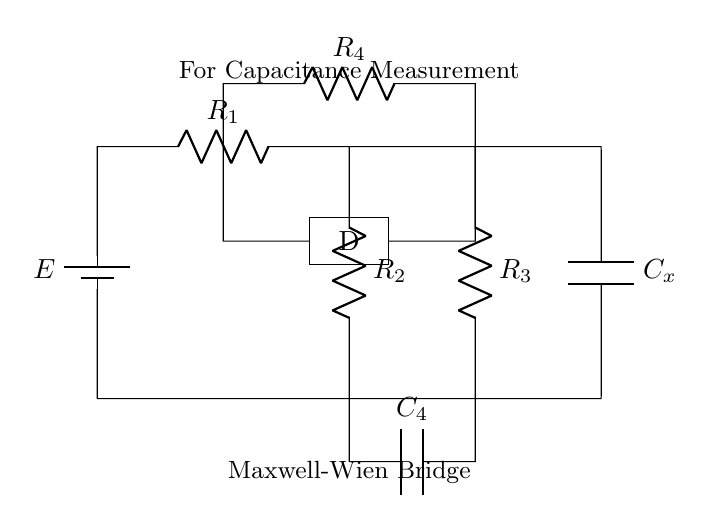What is the role of Cx in the circuit? Cx is a capacitor used for measuring capacitance in the Maxwell-Wien bridge. It is connected in series, allowing for precise capacitance measurements by balancing the bridge circuit.
Answer: capacitor What are the resistor values identified in this bridge? The resistors in the Maxwell-Wien bridge are R1, R2, R3, and R4. Their specific values would typically be provided in another context, but they can vary based on the application.
Answer: R1, R2, R3, R4 What is the purpose of the D component? The D component in the circuit likely represents a detection or measurement device, which indicates the balance of the bridge. It helps in determining if the circuit is balanced for accurate measurements.
Answer: detection device How many capacitors are present in the circuit? There are two capacitors in the Maxwell-Wien bridge: Cx and C4. They play roles in balancing the bridge for capacitance measurement.
Answer: two What is indicated by the labeling on the capacitor Cx? The labeling on the capacitor Cx indicates that it is specifically part of the measurement setup in the Maxwell-Wien bridge, highlighting its significance for determining the unknown capacitance.
Answer: measurement setup How does the configuration of resistors and capacitors aid in precise measurement? The configuration of the resistors and capacitors in the Maxwell-Wien bridge allows for a balance condition to be achieved, where can calculate the unknown capacitance by comparing it against known values, thus providing precise measurements.
Answer: balance condition 